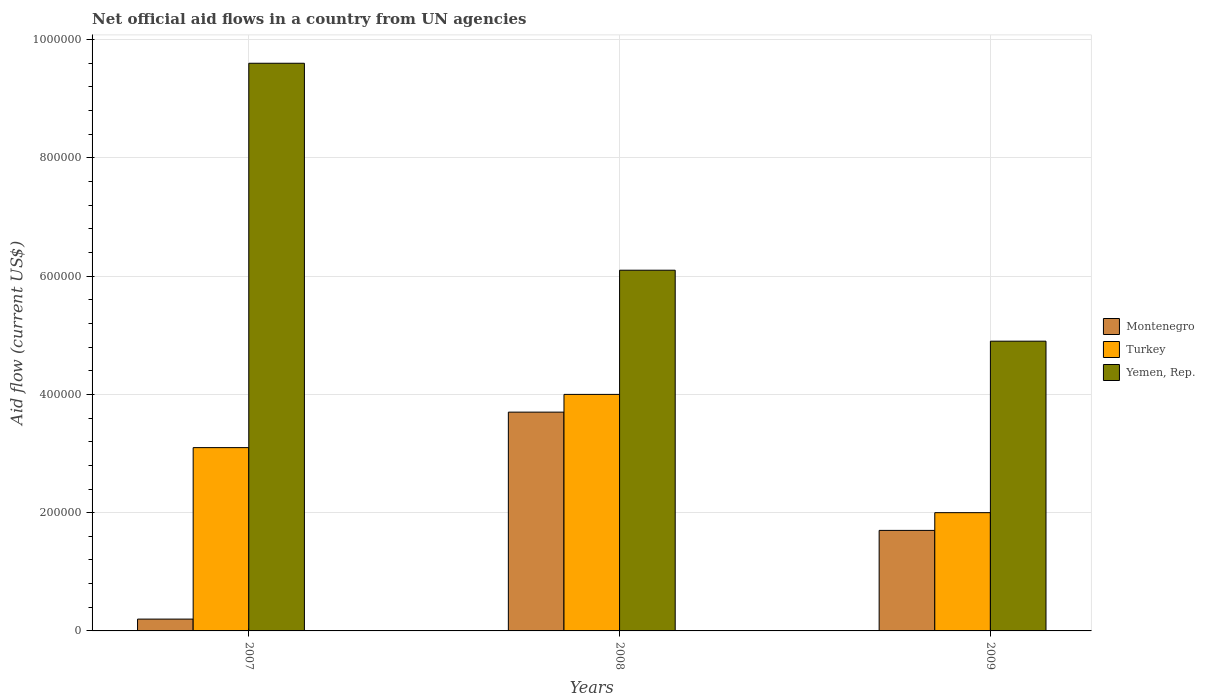How many bars are there on the 1st tick from the left?
Offer a terse response. 3. What is the label of the 2nd group of bars from the left?
Offer a very short reply. 2008. Across all years, what is the minimum net official aid flow in Yemen, Rep.?
Give a very brief answer. 4.90e+05. What is the total net official aid flow in Yemen, Rep. in the graph?
Make the answer very short. 2.06e+06. What is the difference between the net official aid flow in Yemen, Rep. in 2007 and that in 2009?
Offer a terse response. 4.70e+05. What is the average net official aid flow in Yemen, Rep. per year?
Give a very brief answer. 6.87e+05. In the year 2007, what is the difference between the net official aid flow in Yemen, Rep. and net official aid flow in Turkey?
Give a very brief answer. 6.50e+05. In how many years, is the net official aid flow in Yemen, Rep. greater than 400000 US$?
Provide a short and direct response. 3. What is the ratio of the net official aid flow in Montenegro in 2007 to that in 2008?
Keep it short and to the point. 0.05. Is the net official aid flow in Montenegro in 2007 less than that in 2008?
Your answer should be very brief. Yes. Is the difference between the net official aid flow in Yemen, Rep. in 2008 and 2009 greater than the difference between the net official aid flow in Turkey in 2008 and 2009?
Ensure brevity in your answer.  No. What is the difference between the highest and the lowest net official aid flow in Turkey?
Offer a terse response. 2.00e+05. What does the 3rd bar from the left in 2009 represents?
Your response must be concise. Yemen, Rep. What does the 3rd bar from the right in 2007 represents?
Give a very brief answer. Montenegro. Are all the bars in the graph horizontal?
Give a very brief answer. No. How many years are there in the graph?
Give a very brief answer. 3. What is the difference between two consecutive major ticks on the Y-axis?
Offer a very short reply. 2.00e+05. What is the title of the graph?
Give a very brief answer. Net official aid flows in a country from UN agencies. What is the label or title of the Y-axis?
Give a very brief answer. Aid flow (current US$). What is the Aid flow (current US$) in Montenegro in 2007?
Make the answer very short. 2.00e+04. What is the Aid flow (current US$) in Yemen, Rep. in 2007?
Offer a terse response. 9.60e+05. What is the Aid flow (current US$) in Turkey in 2008?
Offer a very short reply. 4.00e+05. What is the Aid flow (current US$) of Yemen, Rep. in 2008?
Offer a very short reply. 6.10e+05. What is the Aid flow (current US$) in Montenegro in 2009?
Your response must be concise. 1.70e+05. Across all years, what is the maximum Aid flow (current US$) of Montenegro?
Your answer should be compact. 3.70e+05. Across all years, what is the maximum Aid flow (current US$) of Yemen, Rep.?
Offer a very short reply. 9.60e+05. Across all years, what is the minimum Aid flow (current US$) of Montenegro?
Your response must be concise. 2.00e+04. Across all years, what is the minimum Aid flow (current US$) in Turkey?
Provide a succinct answer. 2.00e+05. Across all years, what is the minimum Aid flow (current US$) of Yemen, Rep.?
Offer a very short reply. 4.90e+05. What is the total Aid flow (current US$) of Montenegro in the graph?
Provide a short and direct response. 5.60e+05. What is the total Aid flow (current US$) of Turkey in the graph?
Provide a short and direct response. 9.10e+05. What is the total Aid flow (current US$) in Yemen, Rep. in the graph?
Offer a terse response. 2.06e+06. What is the difference between the Aid flow (current US$) in Montenegro in 2007 and that in 2008?
Ensure brevity in your answer.  -3.50e+05. What is the difference between the Aid flow (current US$) in Montenegro in 2007 and that in 2009?
Offer a very short reply. -1.50e+05. What is the difference between the Aid flow (current US$) in Turkey in 2007 and that in 2009?
Make the answer very short. 1.10e+05. What is the difference between the Aid flow (current US$) in Montenegro in 2008 and that in 2009?
Provide a succinct answer. 2.00e+05. What is the difference between the Aid flow (current US$) of Montenegro in 2007 and the Aid flow (current US$) of Turkey in 2008?
Provide a short and direct response. -3.80e+05. What is the difference between the Aid flow (current US$) in Montenegro in 2007 and the Aid flow (current US$) in Yemen, Rep. in 2008?
Provide a succinct answer. -5.90e+05. What is the difference between the Aid flow (current US$) of Turkey in 2007 and the Aid flow (current US$) of Yemen, Rep. in 2008?
Make the answer very short. -3.00e+05. What is the difference between the Aid flow (current US$) in Montenegro in 2007 and the Aid flow (current US$) in Yemen, Rep. in 2009?
Make the answer very short. -4.70e+05. What is the difference between the Aid flow (current US$) of Montenegro in 2008 and the Aid flow (current US$) of Turkey in 2009?
Make the answer very short. 1.70e+05. What is the difference between the Aid flow (current US$) of Montenegro in 2008 and the Aid flow (current US$) of Yemen, Rep. in 2009?
Your answer should be very brief. -1.20e+05. What is the difference between the Aid flow (current US$) in Turkey in 2008 and the Aid flow (current US$) in Yemen, Rep. in 2009?
Make the answer very short. -9.00e+04. What is the average Aid flow (current US$) in Montenegro per year?
Your response must be concise. 1.87e+05. What is the average Aid flow (current US$) of Turkey per year?
Offer a very short reply. 3.03e+05. What is the average Aid flow (current US$) in Yemen, Rep. per year?
Provide a succinct answer. 6.87e+05. In the year 2007, what is the difference between the Aid flow (current US$) of Montenegro and Aid flow (current US$) of Yemen, Rep.?
Make the answer very short. -9.40e+05. In the year 2007, what is the difference between the Aid flow (current US$) in Turkey and Aid flow (current US$) in Yemen, Rep.?
Offer a very short reply. -6.50e+05. In the year 2008, what is the difference between the Aid flow (current US$) of Montenegro and Aid flow (current US$) of Yemen, Rep.?
Provide a succinct answer. -2.40e+05. In the year 2008, what is the difference between the Aid flow (current US$) of Turkey and Aid flow (current US$) of Yemen, Rep.?
Keep it short and to the point. -2.10e+05. In the year 2009, what is the difference between the Aid flow (current US$) in Montenegro and Aid flow (current US$) in Yemen, Rep.?
Provide a short and direct response. -3.20e+05. What is the ratio of the Aid flow (current US$) of Montenegro in 2007 to that in 2008?
Give a very brief answer. 0.05. What is the ratio of the Aid flow (current US$) in Turkey in 2007 to that in 2008?
Offer a terse response. 0.78. What is the ratio of the Aid flow (current US$) in Yemen, Rep. in 2007 to that in 2008?
Make the answer very short. 1.57. What is the ratio of the Aid flow (current US$) of Montenegro in 2007 to that in 2009?
Give a very brief answer. 0.12. What is the ratio of the Aid flow (current US$) of Turkey in 2007 to that in 2009?
Offer a very short reply. 1.55. What is the ratio of the Aid flow (current US$) in Yemen, Rep. in 2007 to that in 2009?
Provide a succinct answer. 1.96. What is the ratio of the Aid flow (current US$) in Montenegro in 2008 to that in 2009?
Make the answer very short. 2.18. What is the ratio of the Aid flow (current US$) of Yemen, Rep. in 2008 to that in 2009?
Make the answer very short. 1.24. What is the difference between the highest and the second highest Aid flow (current US$) in Turkey?
Ensure brevity in your answer.  9.00e+04. What is the difference between the highest and the lowest Aid flow (current US$) in Turkey?
Offer a terse response. 2.00e+05. 